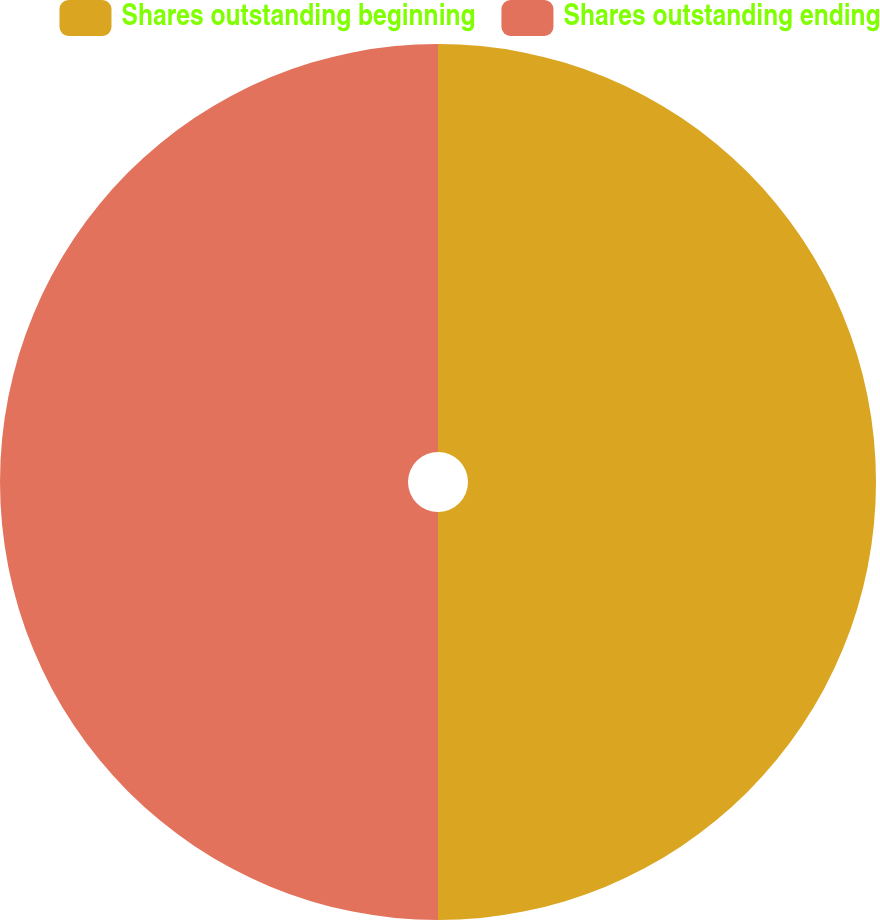Convert chart. <chart><loc_0><loc_0><loc_500><loc_500><pie_chart><fcel>Shares outstanding beginning<fcel>Shares outstanding ending<nl><fcel>50.0%<fcel>50.0%<nl></chart> 